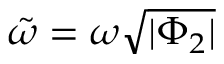<formula> <loc_0><loc_0><loc_500><loc_500>\tilde { \omega } = \omega \sqrt { | \Phi _ { 2 } | }</formula> 